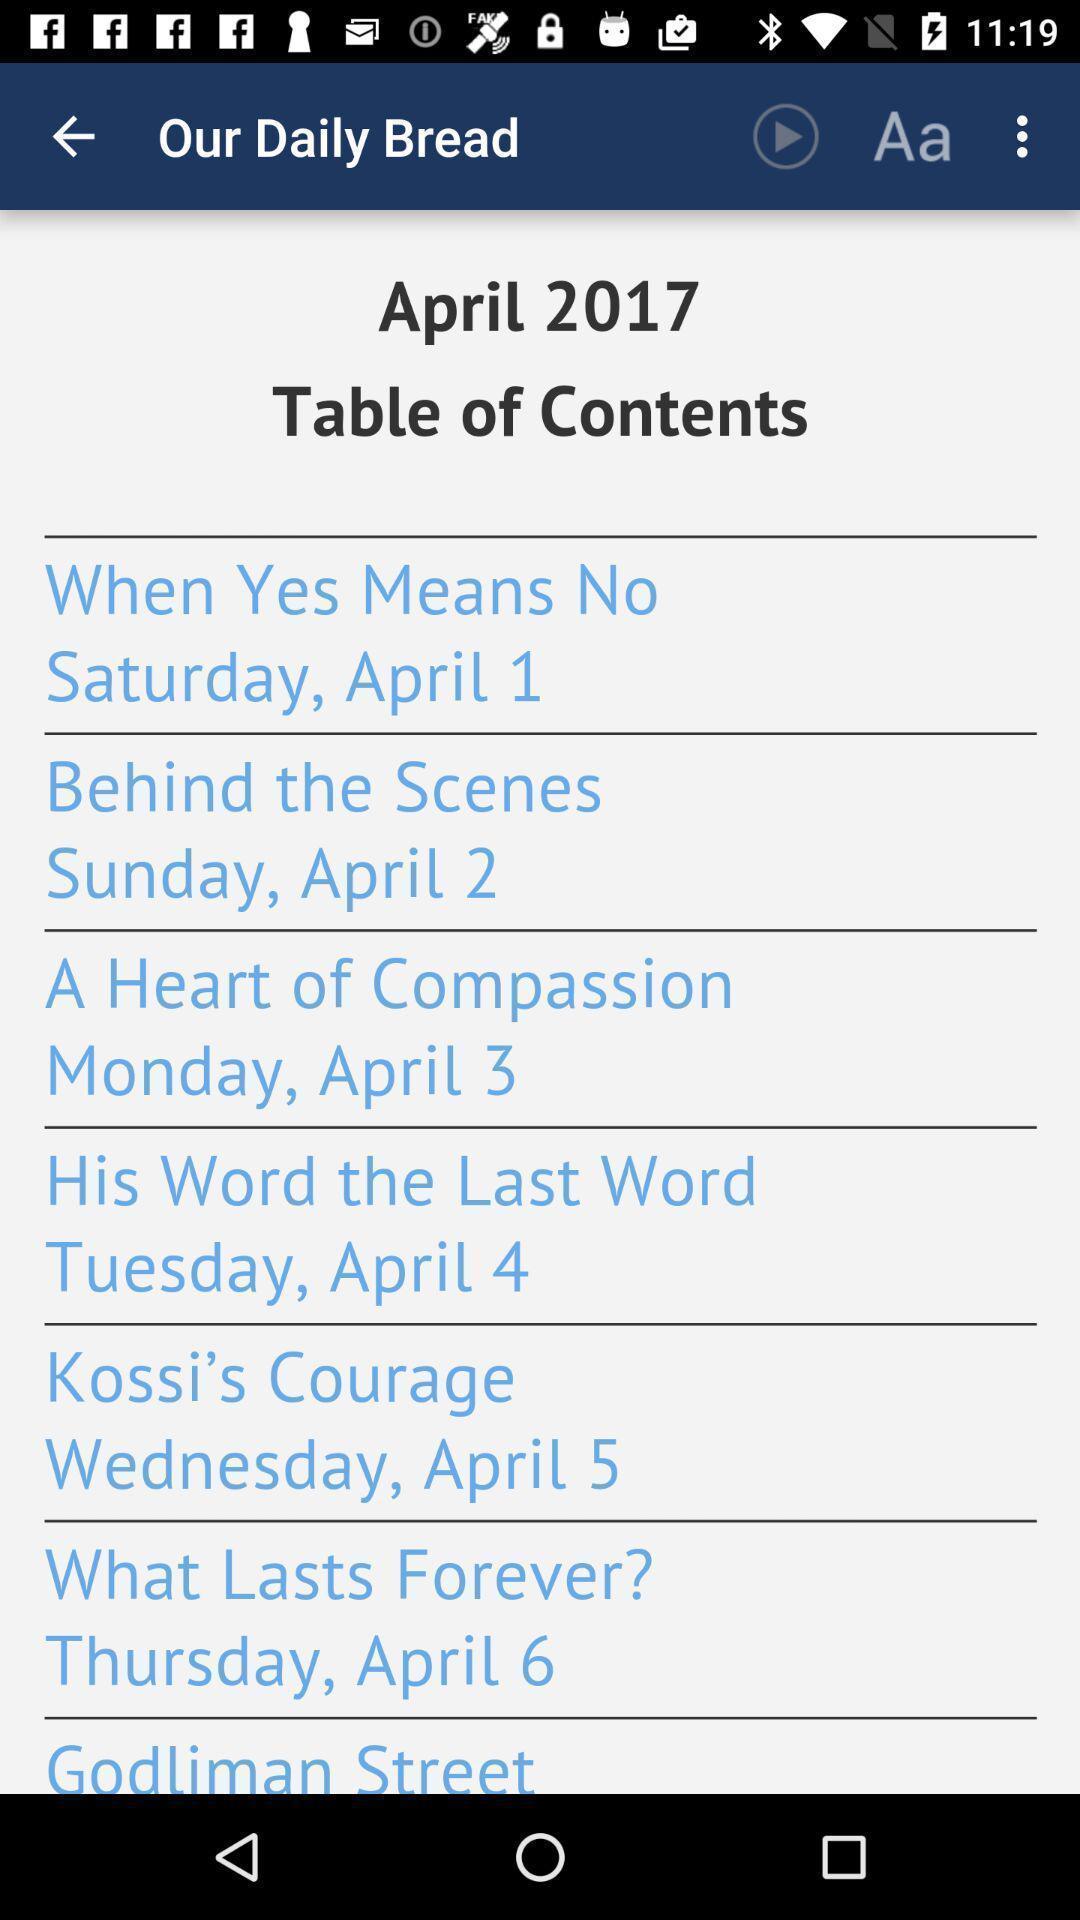Tell me about the visual elements in this screen capture. Page displaying with different contents. 